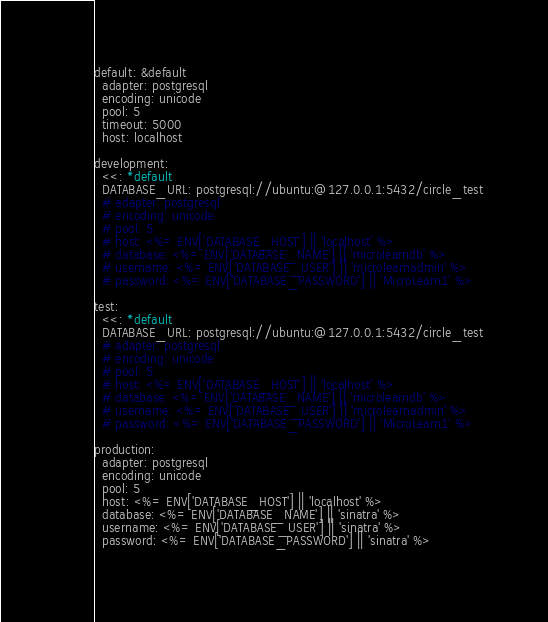Convert code to text. <code><loc_0><loc_0><loc_500><loc_500><_YAML_>default: &default
  adapter: postgresql
  encoding: unicode
  pool: 5
  timeout: 5000
  host: localhost

development:
  <<: *default
  DATABASE_URL: postgresql://ubuntu:@127.0.0.1:5432/circle_test
  # adapter: postgresql
  # encoding: unicode
  # pool: 5
  # host: <%= ENV['DATABASE_HOST'] || 'localhost' %>
  # database: <%= ENV['DATABASE_NAME'] || 'microlearndb' %>
  # username: <%= ENV['DATABASE_USER'] || 'microlearnadmin' %>
  # password: <%= ENV['DATABASE_PASSWORD'] || 'MicroLearn1' %>

test:
  <<: *default
  DATABASE_URL: postgresql://ubuntu:@127.0.0.1:5432/circle_test
  # adapter: postgresql
  # encoding: unicode
  # pool: 5
  # host: <%= ENV['DATABASE_HOST'] || 'localhost' %>
  # database: <%= ENV['DATABASE_NAME'] || 'microlearndb' %>
  # username: <%= ENV['DATABASE_USER'] || 'microlearnadmin' %>
  # password: <%= ENV['DATABASE_PASSWORD'] || 'MicroLearn1' %>

production:
  adapter: postgresql
  encoding: unicode
  pool: 5
  host: <%= ENV['DATABASE_HOST'] || 'localhost' %>
  database: <%= ENV['DATABASE_NAME'] || 'sinatra' %>
  username: <%= ENV['DATABASE_USER'] || 'sinatra' %>
  password: <%= ENV['DATABASE_PASSWORD'] || 'sinatra' %>
  </code> 